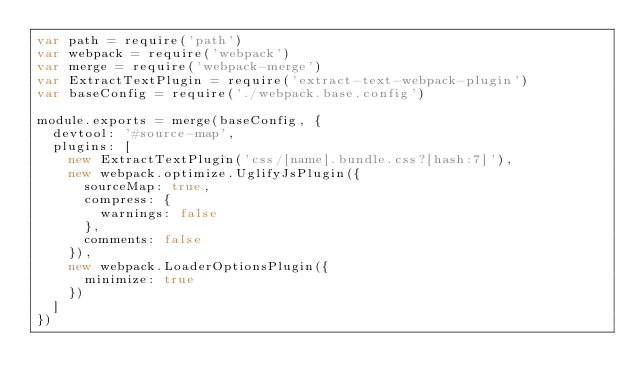Convert code to text. <code><loc_0><loc_0><loc_500><loc_500><_JavaScript_>var path = require('path')
var webpack = require('webpack')
var merge = require('webpack-merge')
var ExtractTextPlugin = require('extract-text-webpack-plugin')
var baseConfig = require('./webpack.base.config')

module.exports = merge(baseConfig, {
  devtool: '#source-map',
  plugins: [
    new ExtractTextPlugin('css/[name].bundle.css?[hash:7]'),
    new webpack.optimize.UglifyJsPlugin({
      sourceMap: true,
      compress: {
        warnings: false
      },
      comments: false
    }),
    new webpack.LoaderOptionsPlugin({
      minimize: true
    })
  ]
})
</code> 